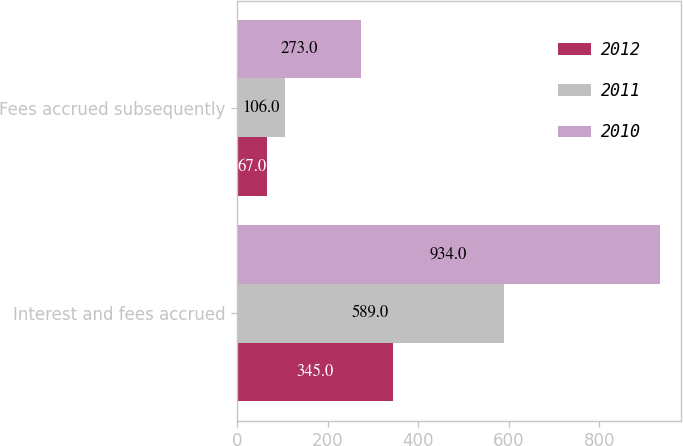Convert chart to OTSL. <chart><loc_0><loc_0><loc_500><loc_500><stacked_bar_chart><ecel><fcel>Interest and fees accrued<fcel>Fees accrued subsequently<nl><fcel>2012<fcel>345<fcel>67<nl><fcel>2011<fcel>589<fcel>106<nl><fcel>2010<fcel>934<fcel>273<nl></chart> 